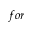<formula> <loc_0><loc_0><loc_500><loc_500>f o r</formula> 